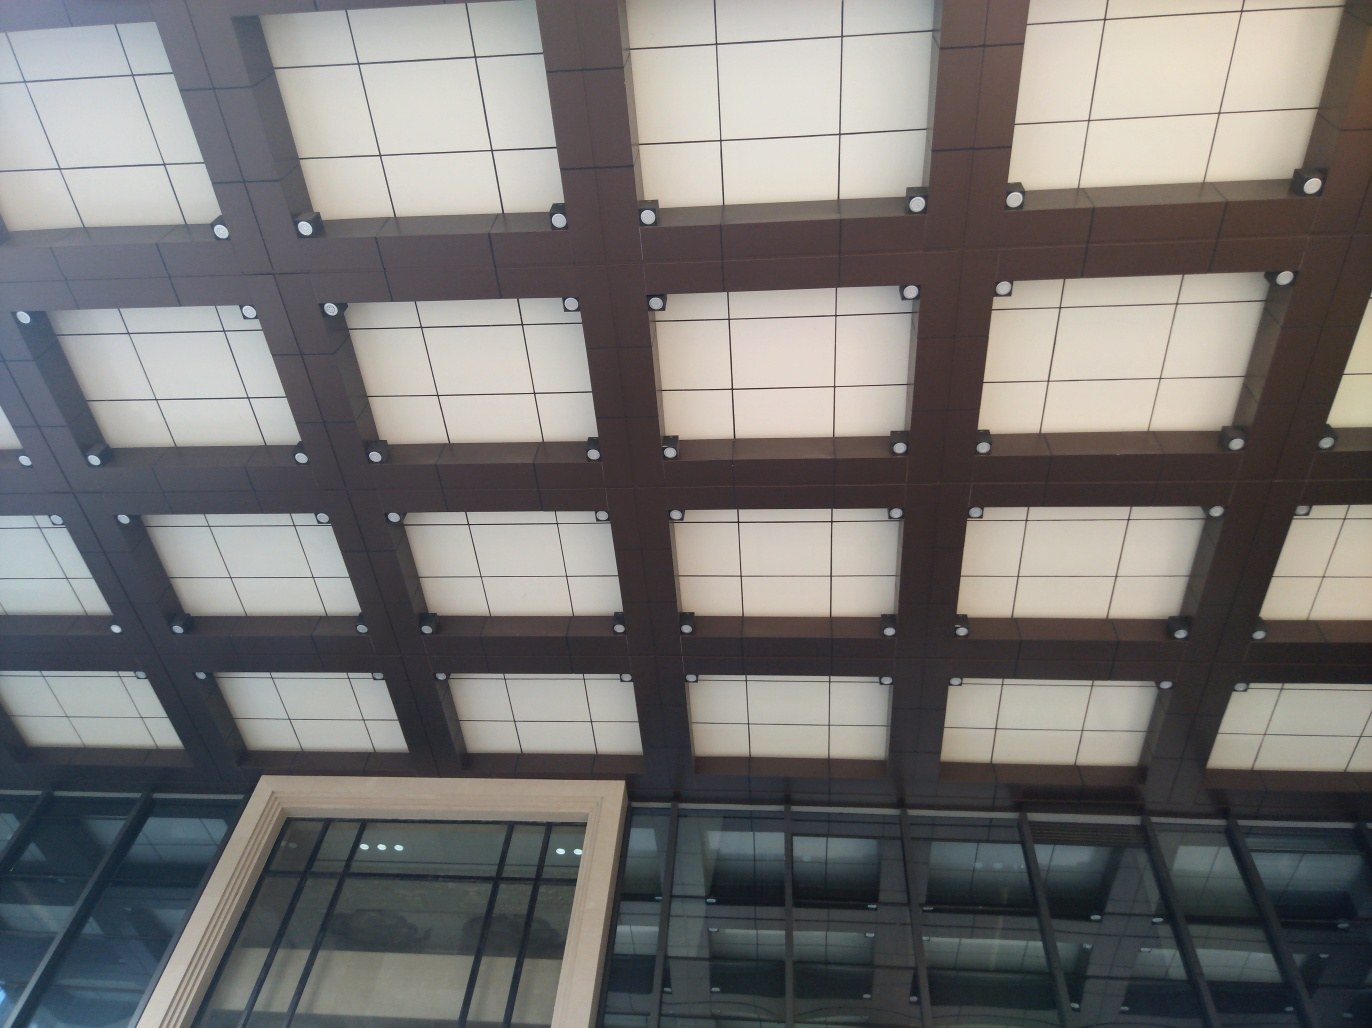Can you describe the lighting situation as seen in the image? The lighting in the image appears to be ambient, possibly natural light filtering through the translucent panels of the ceiling. The reflection and softer glow suggest an indirect light source, creating a diffused effect. 